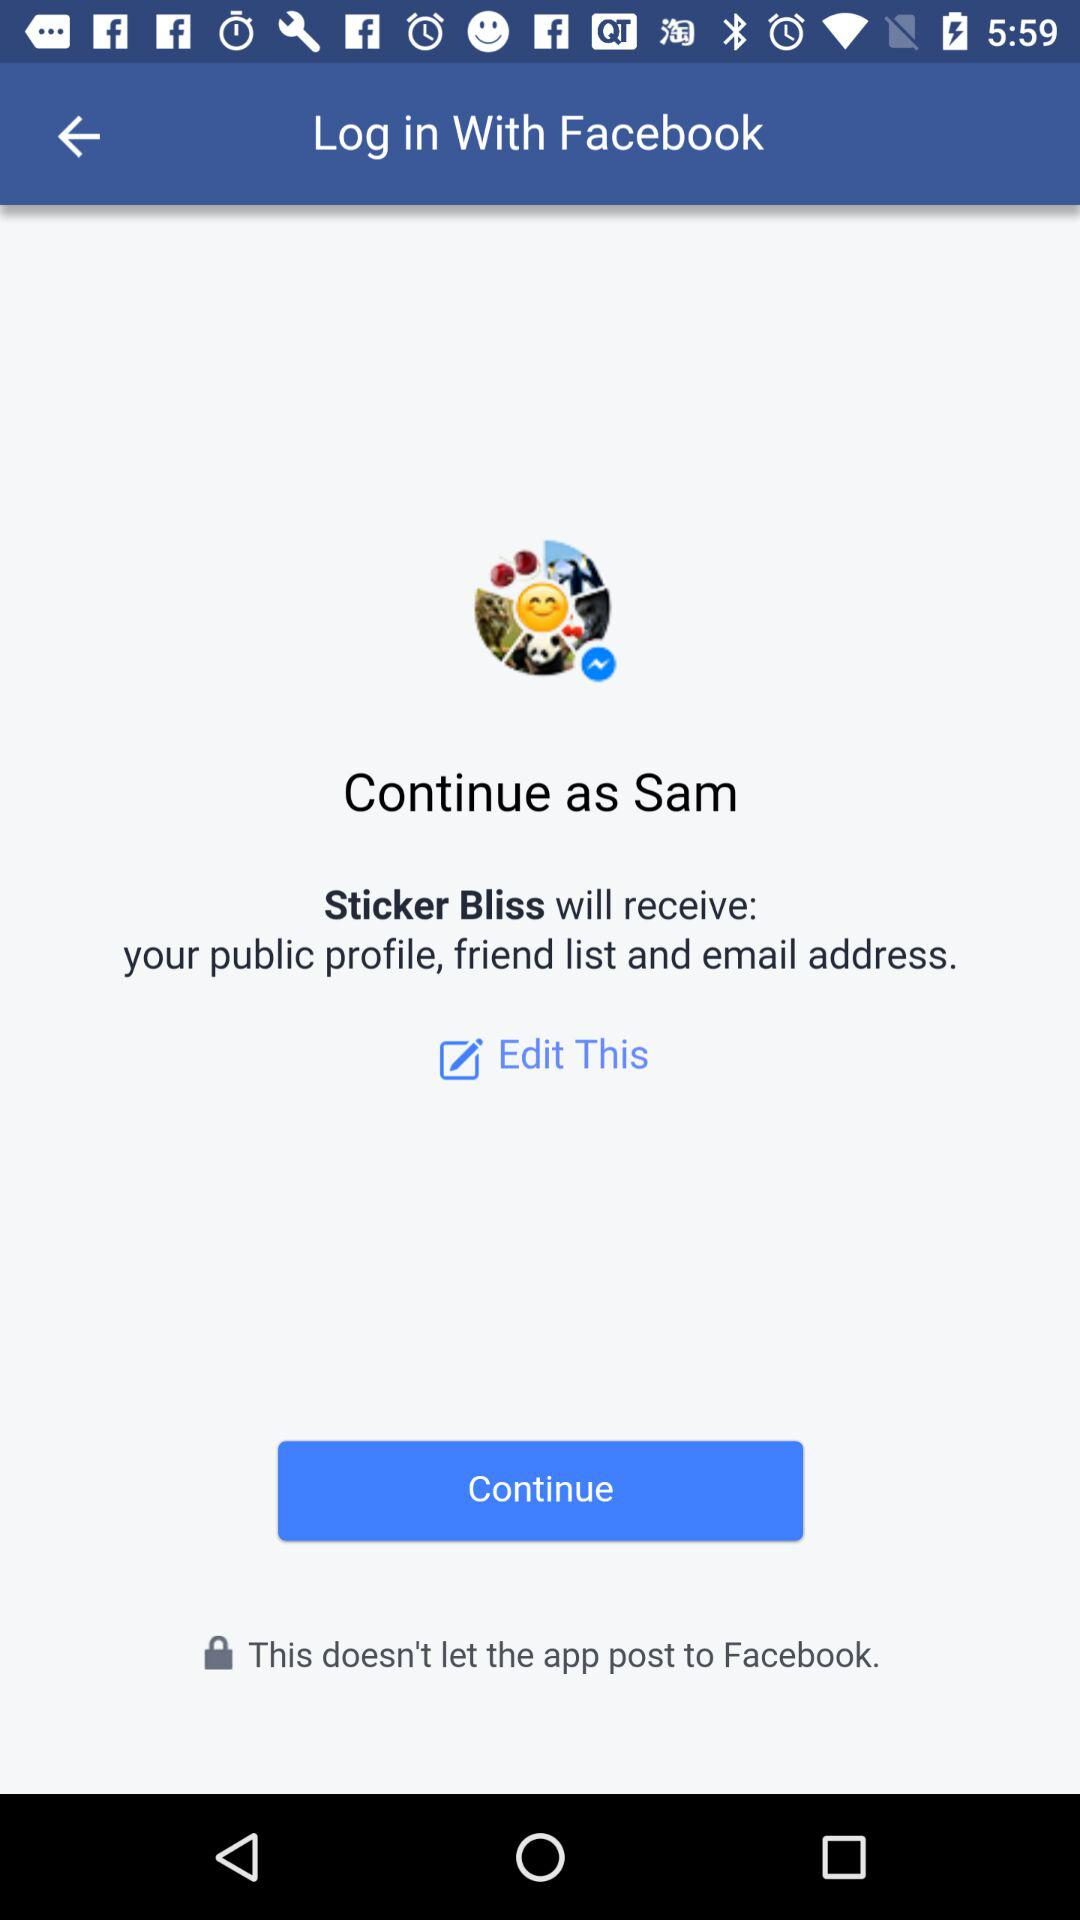What is the name of the user? The name of the user is Sam. 